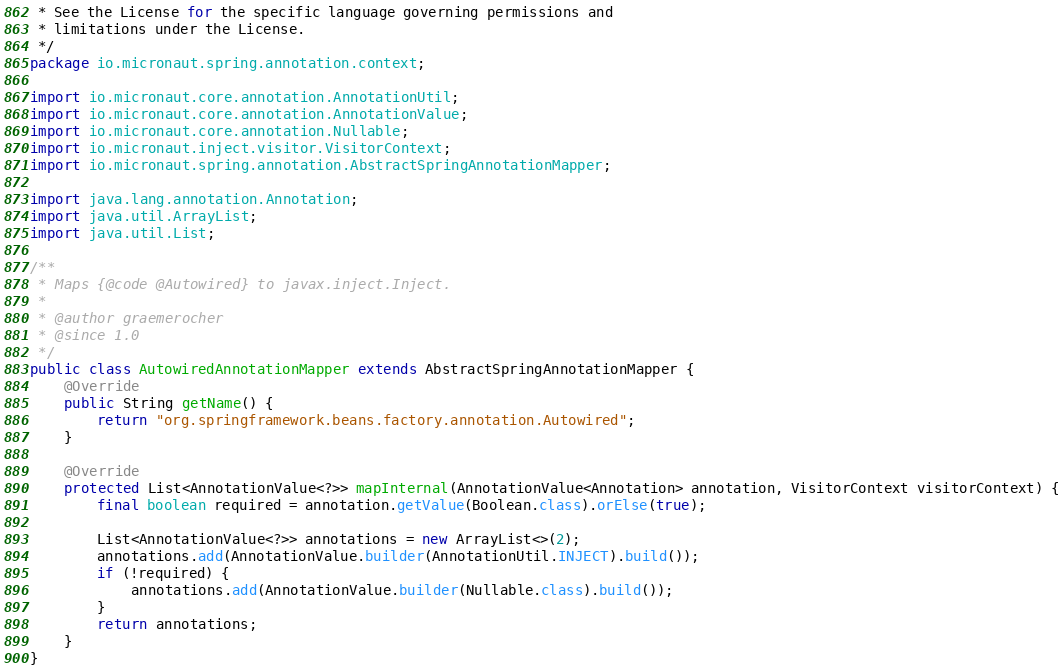<code> <loc_0><loc_0><loc_500><loc_500><_Java_> * See the License for the specific language governing permissions and
 * limitations under the License.
 */
package io.micronaut.spring.annotation.context;

import io.micronaut.core.annotation.AnnotationUtil;
import io.micronaut.core.annotation.AnnotationValue;
import io.micronaut.core.annotation.Nullable;
import io.micronaut.inject.visitor.VisitorContext;
import io.micronaut.spring.annotation.AbstractSpringAnnotationMapper;

import java.lang.annotation.Annotation;
import java.util.ArrayList;
import java.util.List;

/**
 * Maps {@code @Autowired} to javax.inject.Inject.
 *
 * @author graemerocher
 * @since 1.0
 */
public class AutowiredAnnotationMapper extends AbstractSpringAnnotationMapper {
    @Override
    public String getName() {
        return "org.springframework.beans.factory.annotation.Autowired";
    }

    @Override
    protected List<AnnotationValue<?>> mapInternal(AnnotationValue<Annotation> annotation, VisitorContext visitorContext) {
        final boolean required = annotation.getValue(Boolean.class).orElse(true);

        List<AnnotationValue<?>> annotations = new ArrayList<>(2);
        annotations.add(AnnotationValue.builder(AnnotationUtil.INJECT).build());
        if (!required) {
            annotations.add(AnnotationValue.builder(Nullable.class).build());
        }
        return annotations;
    }
}
</code> 